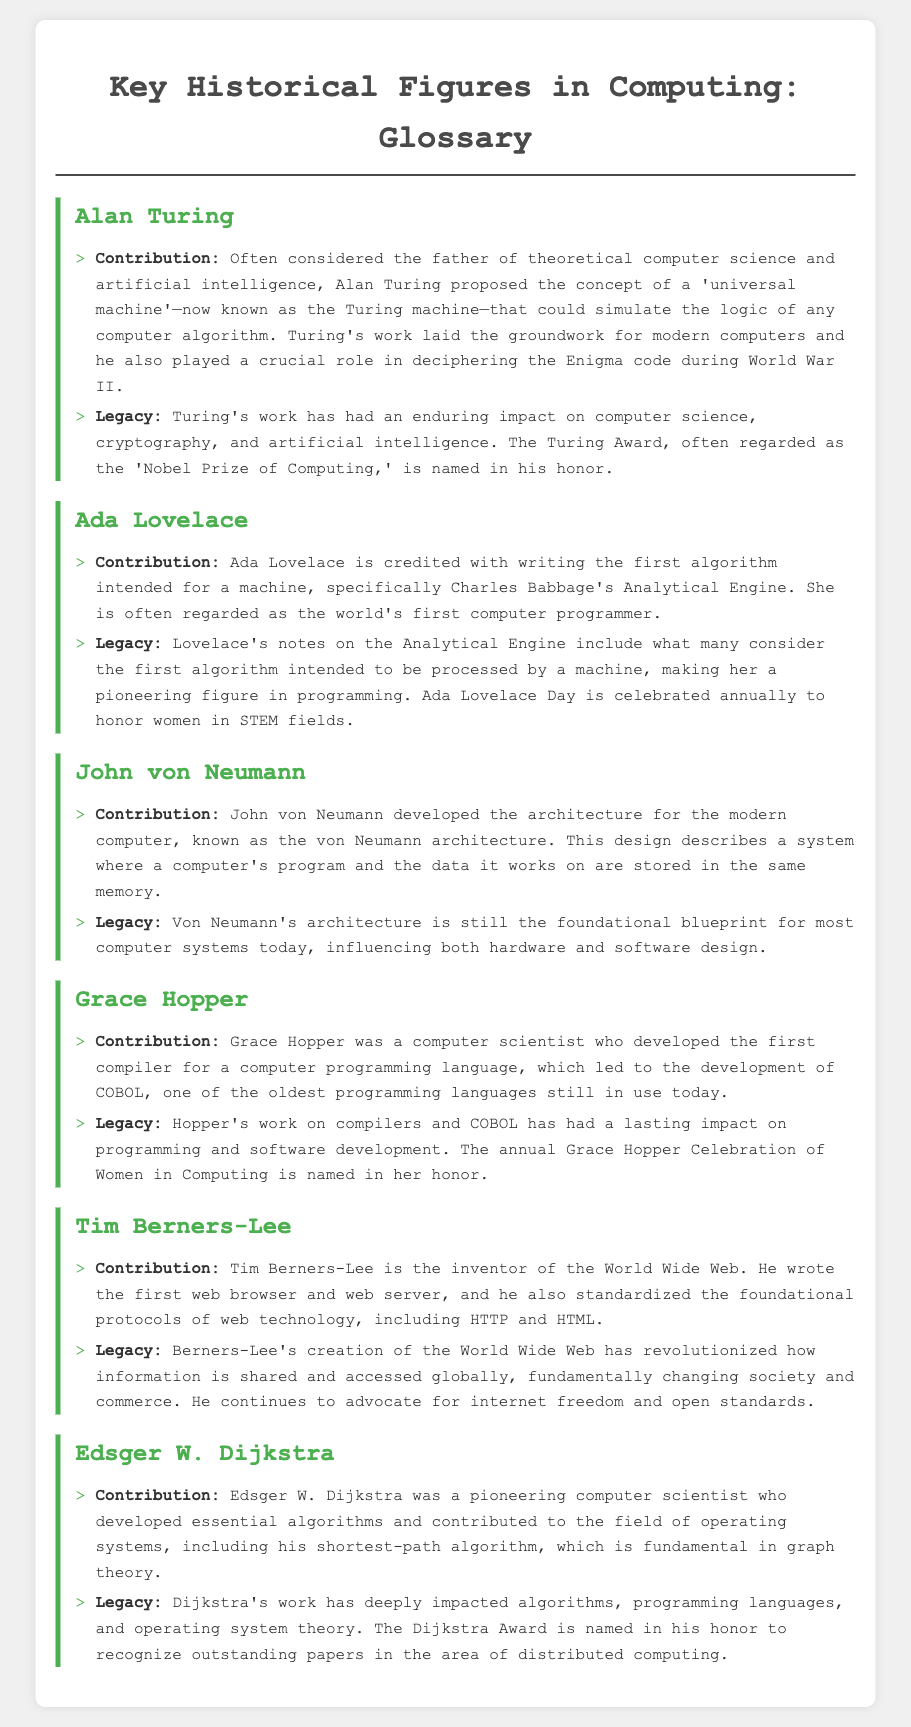What is the contribution of Alan Turing? Alan Turing proposed the concept of a 'universal machine'—now known as the Turing machine— and played a crucial role in deciphering the Enigma code during World War II.
Answer: 'universal machine' Who is considered the first computer programmer? Ada Lovelace is credited with writing the first algorithm intended for a machine, making her the first computer programmer.
Answer: Ada Lovelace What architecture did John von Neumann develop? John von Neumann developed the architecture known as the von Neumann architecture, which describes a system where a computer's program and data are stored in the same memory.
Answer: von Neumann architecture What programming language is associated with Grace Hopper? Grace Hopper developed COBOL, one of the oldest programming languages still in use today.
Answer: COBOL What is Tim Berners-Lee known for inventing? Tim Berners-Lee is known for inventing the World Wide Web, including the first web browser and web server.
Answer: World Wide Web What award is named after Edsger W. Dijkstra? The Dijkstra Award is named in honor of Edsger W. Dijkstra to recognize outstanding papers in the area of distributed computing.
Answer: Dijkstra Award What notable impact did Alan Turing have? Turing's work has had an enduring impact on computer science, cryptography, and artificial intelligence.
Answer: enduring impact Which historical figure is associated with the celebration of women in STEM? Ada Lovelace is honored on Ada Lovelace Day, which celebrates women in STEM fields.
Answer: Ada Lovelace What is the significance of the Turing Award? The Turing Award is often regarded as the 'Nobel Prize of Computing,' named in honor of Alan Turing.
Answer: 'Nobel Prize of Computing' 